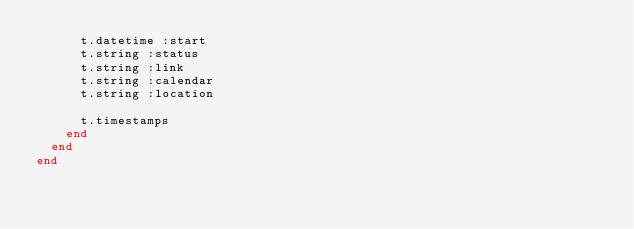Convert code to text. <code><loc_0><loc_0><loc_500><loc_500><_Ruby_>      t.datetime :start
      t.string :status
      t.string :link
      t.string :calendar
      t.string :location

      t.timestamps
    end
  end
end
</code> 